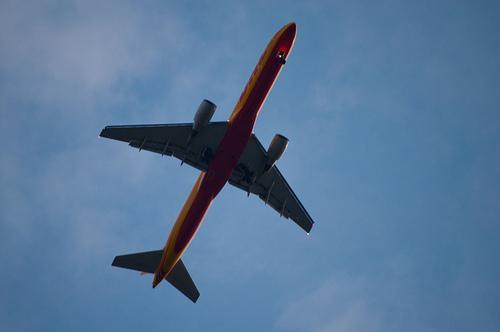How many planes are shown?
Give a very brief answer. 1. 